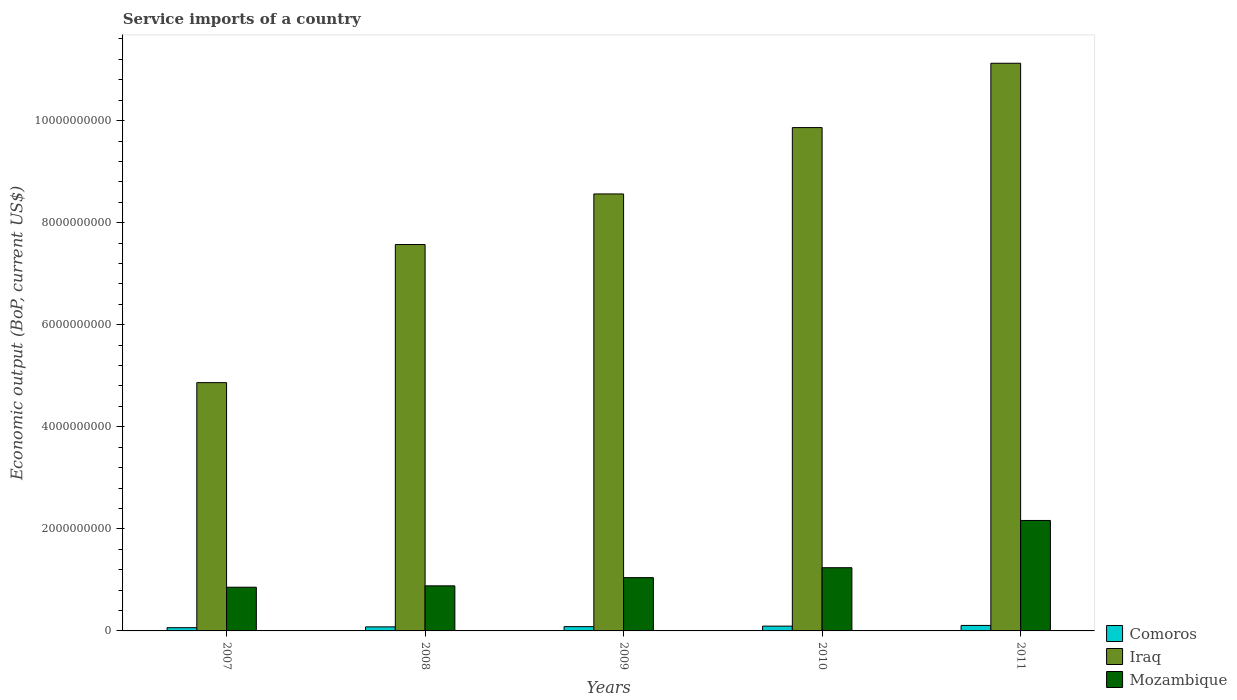Are the number of bars per tick equal to the number of legend labels?
Offer a very short reply. Yes. How many bars are there on the 4th tick from the left?
Provide a succinct answer. 3. How many bars are there on the 4th tick from the right?
Your response must be concise. 3. In how many cases, is the number of bars for a given year not equal to the number of legend labels?
Ensure brevity in your answer.  0. What is the service imports in Mozambique in 2008?
Your answer should be very brief. 8.83e+08. Across all years, what is the maximum service imports in Iraq?
Make the answer very short. 1.11e+1. Across all years, what is the minimum service imports in Mozambique?
Your answer should be compact. 8.57e+08. In which year was the service imports in Comoros maximum?
Offer a very short reply. 2011. In which year was the service imports in Comoros minimum?
Your answer should be very brief. 2007. What is the total service imports in Mozambique in the graph?
Offer a very short reply. 6.19e+09. What is the difference between the service imports in Mozambique in 2008 and that in 2011?
Your response must be concise. -1.28e+09. What is the difference between the service imports in Comoros in 2007 and the service imports in Mozambique in 2011?
Provide a short and direct response. -2.10e+09. What is the average service imports in Comoros per year?
Make the answer very short. 8.57e+07. In the year 2011, what is the difference between the service imports in Comoros and service imports in Mozambique?
Offer a terse response. -2.06e+09. In how many years, is the service imports in Mozambique greater than 4400000000 US$?
Offer a very short reply. 0. What is the ratio of the service imports in Mozambique in 2009 to that in 2010?
Your answer should be very brief. 0.84. Is the service imports in Mozambique in 2009 less than that in 2010?
Offer a terse response. Yes. What is the difference between the highest and the second highest service imports in Comoros?
Ensure brevity in your answer.  1.35e+07. What is the difference between the highest and the lowest service imports in Comoros?
Your answer should be very brief. 4.40e+07. In how many years, is the service imports in Iraq greater than the average service imports in Iraq taken over all years?
Ensure brevity in your answer.  3. What does the 3rd bar from the left in 2011 represents?
Make the answer very short. Mozambique. What does the 3rd bar from the right in 2008 represents?
Make the answer very short. Comoros. Is it the case that in every year, the sum of the service imports in Comoros and service imports in Iraq is greater than the service imports in Mozambique?
Keep it short and to the point. Yes. How many bars are there?
Your response must be concise. 15. Are all the bars in the graph horizontal?
Provide a short and direct response. No. Does the graph contain any zero values?
Ensure brevity in your answer.  No. Does the graph contain grids?
Offer a terse response. No. Where does the legend appear in the graph?
Your answer should be very brief. Bottom right. How many legend labels are there?
Make the answer very short. 3. How are the legend labels stacked?
Your response must be concise. Vertical. What is the title of the graph?
Your response must be concise. Service imports of a country. Does "Grenada" appear as one of the legend labels in the graph?
Offer a very short reply. No. What is the label or title of the Y-axis?
Provide a succinct answer. Economic output (BoP, current US$). What is the Economic output (BoP, current US$) in Comoros in 2007?
Provide a succinct answer. 6.35e+07. What is the Economic output (BoP, current US$) in Iraq in 2007?
Make the answer very short. 4.87e+09. What is the Economic output (BoP, current US$) in Mozambique in 2007?
Keep it short and to the point. 8.57e+08. What is the Economic output (BoP, current US$) in Comoros in 2008?
Your answer should be compact. 7.94e+07. What is the Economic output (BoP, current US$) in Iraq in 2008?
Make the answer very short. 7.57e+09. What is the Economic output (BoP, current US$) of Mozambique in 2008?
Provide a succinct answer. 8.83e+08. What is the Economic output (BoP, current US$) of Comoros in 2009?
Your answer should be very brief. 8.40e+07. What is the Economic output (BoP, current US$) of Iraq in 2009?
Provide a short and direct response. 8.56e+09. What is the Economic output (BoP, current US$) in Mozambique in 2009?
Provide a succinct answer. 1.04e+09. What is the Economic output (BoP, current US$) in Comoros in 2010?
Provide a succinct answer. 9.40e+07. What is the Economic output (BoP, current US$) in Iraq in 2010?
Your response must be concise. 9.86e+09. What is the Economic output (BoP, current US$) of Mozambique in 2010?
Offer a very short reply. 1.24e+09. What is the Economic output (BoP, current US$) of Comoros in 2011?
Offer a terse response. 1.08e+08. What is the Economic output (BoP, current US$) of Iraq in 2011?
Give a very brief answer. 1.11e+1. What is the Economic output (BoP, current US$) of Mozambique in 2011?
Your response must be concise. 2.16e+09. Across all years, what is the maximum Economic output (BoP, current US$) of Comoros?
Provide a short and direct response. 1.08e+08. Across all years, what is the maximum Economic output (BoP, current US$) in Iraq?
Your answer should be compact. 1.11e+1. Across all years, what is the maximum Economic output (BoP, current US$) in Mozambique?
Your response must be concise. 2.16e+09. Across all years, what is the minimum Economic output (BoP, current US$) of Comoros?
Provide a succinct answer. 6.35e+07. Across all years, what is the minimum Economic output (BoP, current US$) in Iraq?
Provide a succinct answer. 4.87e+09. Across all years, what is the minimum Economic output (BoP, current US$) in Mozambique?
Keep it short and to the point. 8.57e+08. What is the total Economic output (BoP, current US$) of Comoros in the graph?
Make the answer very short. 4.28e+08. What is the total Economic output (BoP, current US$) of Iraq in the graph?
Ensure brevity in your answer.  4.20e+1. What is the total Economic output (BoP, current US$) in Mozambique in the graph?
Keep it short and to the point. 6.19e+09. What is the difference between the Economic output (BoP, current US$) of Comoros in 2007 and that in 2008?
Provide a short and direct response. -1.60e+07. What is the difference between the Economic output (BoP, current US$) of Iraq in 2007 and that in 2008?
Your response must be concise. -2.71e+09. What is the difference between the Economic output (BoP, current US$) of Mozambique in 2007 and that in 2008?
Offer a terse response. -2.68e+07. What is the difference between the Economic output (BoP, current US$) in Comoros in 2007 and that in 2009?
Ensure brevity in your answer.  -2.06e+07. What is the difference between the Economic output (BoP, current US$) of Iraq in 2007 and that in 2009?
Give a very brief answer. -3.70e+09. What is the difference between the Economic output (BoP, current US$) in Mozambique in 2007 and that in 2009?
Your answer should be very brief. -1.88e+08. What is the difference between the Economic output (BoP, current US$) in Comoros in 2007 and that in 2010?
Ensure brevity in your answer.  -3.05e+07. What is the difference between the Economic output (BoP, current US$) of Iraq in 2007 and that in 2010?
Offer a terse response. -5.00e+09. What is the difference between the Economic output (BoP, current US$) in Mozambique in 2007 and that in 2010?
Offer a terse response. -3.82e+08. What is the difference between the Economic output (BoP, current US$) in Comoros in 2007 and that in 2011?
Ensure brevity in your answer.  -4.40e+07. What is the difference between the Economic output (BoP, current US$) of Iraq in 2007 and that in 2011?
Make the answer very short. -6.26e+09. What is the difference between the Economic output (BoP, current US$) of Mozambique in 2007 and that in 2011?
Your answer should be compact. -1.31e+09. What is the difference between the Economic output (BoP, current US$) in Comoros in 2008 and that in 2009?
Keep it short and to the point. -4.60e+06. What is the difference between the Economic output (BoP, current US$) of Iraq in 2008 and that in 2009?
Provide a succinct answer. -9.91e+08. What is the difference between the Economic output (BoP, current US$) of Mozambique in 2008 and that in 2009?
Offer a very short reply. -1.61e+08. What is the difference between the Economic output (BoP, current US$) in Comoros in 2008 and that in 2010?
Your response must be concise. -1.45e+07. What is the difference between the Economic output (BoP, current US$) of Iraq in 2008 and that in 2010?
Provide a short and direct response. -2.29e+09. What is the difference between the Economic output (BoP, current US$) of Mozambique in 2008 and that in 2010?
Keep it short and to the point. -3.56e+08. What is the difference between the Economic output (BoP, current US$) in Comoros in 2008 and that in 2011?
Provide a short and direct response. -2.81e+07. What is the difference between the Economic output (BoP, current US$) in Iraq in 2008 and that in 2011?
Your answer should be very brief. -3.55e+09. What is the difference between the Economic output (BoP, current US$) of Mozambique in 2008 and that in 2011?
Ensure brevity in your answer.  -1.28e+09. What is the difference between the Economic output (BoP, current US$) of Comoros in 2009 and that in 2010?
Offer a terse response. -9.95e+06. What is the difference between the Economic output (BoP, current US$) in Iraq in 2009 and that in 2010?
Your answer should be compact. -1.30e+09. What is the difference between the Economic output (BoP, current US$) of Mozambique in 2009 and that in 2010?
Your answer should be very brief. -1.95e+08. What is the difference between the Economic output (BoP, current US$) of Comoros in 2009 and that in 2011?
Ensure brevity in your answer.  -2.35e+07. What is the difference between the Economic output (BoP, current US$) of Iraq in 2009 and that in 2011?
Your answer should be very brief. -2.56e+09. What is the difference between the Economic output (BoP, current US$) in Mozambique in 2009 and that in 2011?
Keep it short and to the point. -1.12e+09. What is the difference between the Economic output (BoP, current US$) of Comoros in 2010 and that in 2011?
Offer a terse response. -1.35e+07. What is the difference between the Economic output (BoP, current US$) of Iraq in 2010 and that in 2011?
Your answer should be compact. -1.26e+09. What is the difference between the Economic output (BoP, current US$) of Mozambique in 2010 and that in 2011?
Offer a terse response. -9.26e+08. What is the difference between the Economic output (BoP, current US$) of Comoros in 2007 and the Economic output (BoP, current US$) of Iraq in 2008?
Offer a terse response. -7.51e+09. What is the difference between the Economic output (BoP, current US$) of Comoros in 2007 and the Economic output (BoP, current US$) of Mozambique in 2008?
Provide a succinct answer. -8.20e+08. What is the difference between the Economic output (BoP, current US$) of Iraq in 2007 and the Economic output (BoP, current US$) of Mozambique in 2008?
Provide a succinct answer. 3.98e+09. What is the difference between the Economic output (BoP, current US$) in Comoros in 2007 and the Economic output (BoP, current US$) in Iraq in 2009?
Your answer should be very brief. -8.50e+09. What is the difference between the Economic output (BoP, current US$) of Comoros in 2007 and the Economic output (BoP, current US$) of Mozambique in 2009?
Make the answer very short. -9.81e+08. What is the difference between the Economic output (BoP, current US$) in Iraq in 2007 and the Economic output (BoP, current US$) in Mozambique in 2009?
Offer a very short reply. 3.82e+09. What is the difference between the Economic output (BoP, current US$) of Comoros in 2007 and the Economic output (BoP, current US$) of Iraq in 2010?
Provide a short and direct response. -9.80e+09. What is the difference between the Economic output (BoP, current US$) of Comoros in 2007 and the Economic output (BoP, current US$) of Mozambique in 2010?
Provide a short and direct response. -1.18e+09. What is the difference between the Economic output (BoP, current US$) of Iraq in 2007 and the Economic output (BoP, current US$) of Mozambique in 2010?
Keep it short and to the point. 3.63e+09. What is the difference between the Economic output (BoP, current US$) of Comoros in 2007 and the Economic output (BoP, current US$) of Iraq in 2011?
Give a very brief answer. -1.11e+1. What is the difference between the Economic output (BoP, current US$) in Comoros in 2007 and the Economic output (BoP, current US$) in Mozambique in 2011?
Provide a succinct answer. -2.10e+09. What is the difference between the Economic output (BoP, current US$) of Iraq in 2007 and the Economic output (BoP, current US$) of Mozambique in 2011?
Make the answer very short. 2.70e+09. What is the difference between the Economic output (BoP, current US$) in Comoros in 2008 and the Economic output (BoP, current US$) in Iraq in 2009?
Make the answer very short. -8.48e+09. What is the difference between the Economic output (BoP, current US$) in Comoros in 2008 and the Economic output (BoP, current US$) in Mozambique in 2009?
Your answer should be very brief. -9.65e+08. What is the difference between the Economic output (BoP, current US$) of Iraq in 2008 and the Economic output (BoP, current US$) of Mozambique in 2009?
Provide a short and direct response. 6.53e+09. What is the difference between the Economic output (BoP, current US$) of Comoros in 2008 and the Economic output (BoP, current US$) of Iraq in 2010?
Keep it short and to the point. -9.78e+09. What is the difference between the Economic output (BoP, current US$) in Comoros in 2008 and the Economic output (BoP, current US$) in Mozambique in 2010?
Your answer should be very brief. -1.16e+09. What is the difference between the Economic output (BoP, current US$) in Iraq in 2008 and the Economic output (BoP, current US$) in Mozambique in 2010?
Offer a very short reply. 6.33e+09. What is the difference between the Economic output (BoP, current US$) of Comoros in 2008 and the Economic output (BoP, current US$) of Iraq in 2011?
Your answer should be compact. -1.10e+1. What is the difference between the Economic output (BoP, current US$) in Comoros in 2008 and the Economic output (BoP, current US$) in Mozambique in 2011?
Keep it short and to the point. -2.09e+09. What is the difference between the Economic output (BoP, current US$) of Iraq in 2008 and the Economic output (BoP, current US$) of Mozambique in 2011?
Your answer should be compact. 5.41e+09. What is the difference between the Economic output (BoP, current US$) of Comoros in 2009 and the Economic output (BoP, current US$) of Iraq in 2010?
Your response must be concise. -9.78e+09. What is the difference between the Economic output (BoP, current US$) of Comoros in 2009 and the Economic output (BoP, current US$) of Mozambique in 2010?
Keep it short and to the point. -1.15e+09. What is the difference between the Economic output (BoP, current US$) of Iraq in 2009 and the Economic output (BoP, current US$) of Mozambique in 2010?
Give a very brief answer. 7.32e+09. What is the difference between the Economic output (BoP, current US$) of Comoros in 2009 and the Economic output (BoP, current US$) of Iraq in 2011?
Offer a very short reply. -1.10e+1. What is the difference between the Economic output (BoP, current US$) in Comoros in 2009 and the Economic output (BoP, current US$) in Mozambique in 2011?
Offer a very short reply. -2.08e+09. What is the difference between the Economic output (BoP, current US$) of Iraq in 2009 and the Economic output (BoP, current US$) of Mozambique in 2011?
Give a very brief answer. 6.40e+09. What is the difference between the Economic output (BoP, current US$) of Comoros in 2010 and the Economic output (BoP, current US$) of Iraq in 2011?
Ensure brevity in your answer.  -1.10e+1. What is the difference between the Economic output (BoP, current US$) of Comoros in 2010 and the Economic output (BoP, current US$) of Mozambique in 2011?
Keep it short and to the point. -2.07e+09. What is the difference between the Economic output (BoP, current US$) in Iraq in 2010 and the Economic output (BoP, current US$) in Mozambique in 2011?
Your answer should be compact. 7.70e+09. What is the average Economic output (BoP, current US$) in Comoros per year?
Give a very brief answer. 8.57e+07. What is the average Economic output (BoP, current US$) of Iraq per year?
Make the answer very short. 8.40e+09. What is the average Economic output (BoP, current US$) in Mozambique per year?
Offer a terse response. 1.24e+09. In the year 2007, what is the difference between the Economic output (BoP, current US$) of Comoros and Economic output (BoP, current US$) of Iraq?
Offer a terse response. -4.80e+09. In the year 2007, what is the difference between the Economic output (BoP, current US$) in Comoros and Economic output (BoP, current US$) in Mozambique?
Keep it short and to the point. -7.93e+08. In the year 2007, what is the difference between the Economic output (BoP, current US$) of Iraq and Economic output (BoP, current US$) of Mozambique?
Offer a very short reply. 4.01e+09. In the year 2008, what is the difference between the Economic output (BoP, current US$) of Comoros and Economic output (BoP, current US$) of Iraq?
Make the answer very short. -7.49e+09. In the year 2008, what is the difference between the Economic output (BoP, current US$) in Comoros and Economic output (BoP, current US$) in Mozambique?
Offer a very short reply. -8.04e+08. In the year 2008, what is the difference between the Economic output (BoP, current US$) in Iraq and Economic output (BoP, current US$) in Mozambique?
Provide a succinct answer. 6.69e+09. In the year 2009, what is the difference between the Economic output (BoP, current US$) in Comoros and Economic output (BoP, current US$) in Iraq?
Make the answer very short. -8.48e+09. In the year 2009, what is the difference between the Economic output (BoP, current US$) of Comoros and Economic output (BoP, current US$) of Mozambique?
Give a very brief answer. -9.60e+08. In the year 2009, what is the difference between the Economic output (BoP, current US$) in Iraq and Economic output (BoP, current US$) in Mozambique?
Provide a short and direct response. 7.52e+09. In the year 2010, what is the difference between the Economic output (BoP, current US$) in Comoros and Economic output (BoP, current US$) in Iraq?
Offer a terse response. -9.77e+09. In the year 2010, what is the difference between the Economic output (BoP, current US$) in Comoros and Economic output (BoP, current US$) in Mozambique?
Provide a succinct answer. -1.14e+09. In the year 2010, what is the difference between the Economic output (BoP, current US$) of Iraq and Economic output (BoP, current US$) of Mozambique?
Ensure brevity in your answer.  8.62e+09. In the year 2011, what is the difference between the Economic output (BoP, current US$) of Comoros and Economic output (BoP, current US$) of Iraq?
Make the answer very short. -1.10e+1. In the year 2011, what is the difference between the Economic output (BoP, current US$) in Comoros and Economic output (BoP, current US$) in Mozambique?
Provide a succinct answer. -2.06e+09. In the year 2011, what is the difference between the Economic output (BoP, current US$) in Iraq and Economic output (BoP, current US$) in Mozambique?
Your answer should be compact. 8.96e+09. What is the ratio of the Economic output (BoP, current US$) of Comoros in 2007 to that in 2008?
Provide a short and direct response. 0.8. What is the ratio of the Economic output (BoP, current US$) of Iraq in 2007 to that in 2008?
Ensure brevity in your answer.  0.64. What is the ratio of the Economic output (BoP, current US$) of Mozambique in 2007 to that in 2008?
Give a very brief answer. 0.97. What is the ratio of the Economic output (BoP, current US$) of Comoros in 2007 to that in 2009?
Offer a very short reply. 0.76. What is the ratio of the Economic output (BoP, current US$) in Iraq in 2007 to that in 2009?
Ensure brevity in your answer.  0.57. What is the ratio of the Economic output (BoP, current US$) of Mozambique in 2007 to that in 2009?
Offer a very short reply. 0.82. What is the ratio of the Economic output (BoP, current US$) in Comoros in 2007 to that in 2010?
Make the answer very short. 0.68. What is the ratio of the Economic output (BoP, current US$) of Iraq in 2007 to that in 2010?
Your answer should be compact. 0.49. What is the ratio of the Economic output (BoP, current US$) in Mozambique in 2007 to that in 2010?
Make the answer very short. 0.69. What is the ratio of the Economic output (BoP, current US$) in Comoros in 2007 to that in 2011?
Your response must be concise. 0.59. What is the ratio of the Economic output (BoP, current US$) in Iraq in 2007 to that in 2011?
Provide a short and direct response. 0.44. What is the ratio of the Economic output (BoP, current US$) in Mozambique in 2007 to that in 2011?
Provide a succinct answer. 0.4. What is the ratio of the Economic output (BoP, current US$) in Comoros in 2008 to that in 2009?
Offer a very short reply. 0.95. What is the ratio of the Economic output (BoP, current US$) of Iraq in 2008 to that in 2009?
Offer a very short reply. 0.88. What is the ratio of the Economic output (BoP, current US$) of Mozambique in 2008 to that in 2009?
Provide a short and direct response. 0.85. What is the ratio of the Economic output (BoP, current US$) in Comoros in 2008 to that in 2010?
Give a very brief answer. 0.85. What is the ratio of the Economic output (BoP, current US$) in Iraq in 2008 to that in 2010?
Your answer should be compact. 0.77. What is the ratio of the Economic output (BoP, current US$) of Mozambique in 2008 to that in 2010?
Make the answer very short. 0.71. What is the ratio of the Economic output (BoP, current US$) in Comoros in 2008 to that in 2011?
Ensure brevity in your answer.  0.74. What is the ratio of the Economic output (BoP, current US$) of Iraq in 2008 to that in 2011?
Your response must be concise. 0.68. What is the ratio of the Economic output (BoP, current US$) of Mozambique in 2008 to that in 2011?
Give a very brief answer. 0.41. What is the ratio of the Economic output (BoP, current US$) in Comoros in 2009 to that in 2010?
Your answer should be very brief. 0.89. What is the ratio of the Economic output (BoP, current US$) in Iraq in 2009 to that in 2010?
Your answer should be compact. 0.87. What is the ratio of the Economic output (BoP, current US$) in Mozambique in 2009 to that in 2010?
Keep it short and to the point. 0.84. What is the ratio of the Economic output (BoP, current US$) in Comoros in 2009 to that in 2011?
Offer a terse response. 0.78. What is the ratio of the Economic output (BoP, current US$) in Iraq in 2009 to that in 2011?
Ensure brevity in your answer.  0.77. What is the ratio of the Economic output (BoP, current US$) in Mozambique in 2009 to that in 2011?
Provide a short and direct response. 0.48. What is the ratio of the Economic output (BoP, current US$) in Comoros in 2010 to that in 2011?
Your answer should be compact. 0.87. What is the ratio of the Economic output (BoP, current US$) of Iraq in 2010 to that in 2011?
Provide a succinct answer. 0.89. What is the ratio of the Economic output (BoP, current US$) in Mozambique in 2010 to that in 2011?
Offer a very short reply. 0.57. What is the difference between the highest and the second highest Economic output (BoP, current US$) of Comoros?
Your answer should be very brief. 1.35e+07. What is the difference between the highest and the second highest Economic output (BoP, current US$) in Iraq?
Your answer should be compact. 1.26e+09. What is the difference between the highest and the second highest Economic output (BoP, current US$) in Mozambique?
Ensure brevity in your answer.  9.26e+08. What is the difference between the highest and the lowest Economic output (BoP, current US$) in Comoros?
Offer a terse response. 4.40e+07. What is the difference between the highest and the lowest Economic output (BoP, current US$) in Iraq?
Offer a very short reply. 6.26e+09. What is the difference between the highest and the lowest Economic output (BoP, current US$) in Mozambique?
Your answer should be very brief. 1.31e+09. 